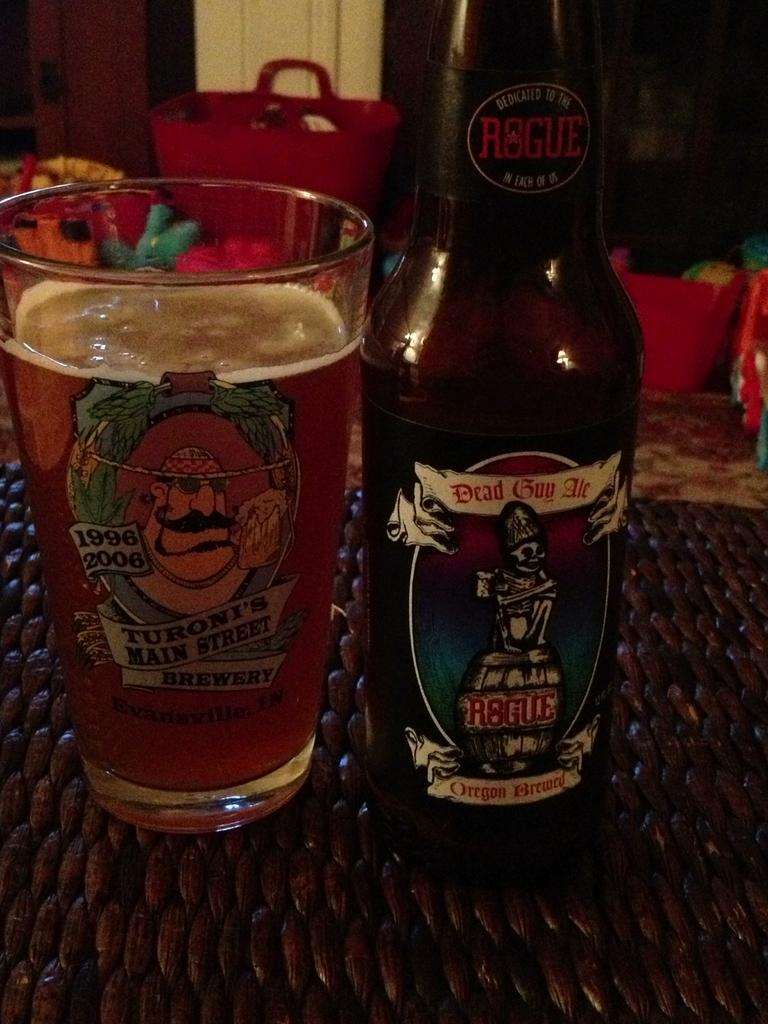Provide a one-sentence caption for the provided image. A bottle of Dead Guy Ale sits beside a glass filled with liquid. 